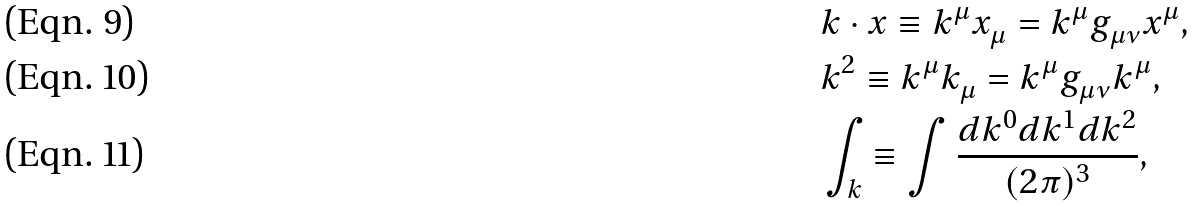Convert formula to latex. <formula><loc_0><loc_0><loc_500><loc_500>& k \cdot x \equiv k ^ { \mu } x ^ { \ } _ { \mu } = k ^ { \mu } g ^ { \ } _ { \mu \nu } x ^ { \mu } , \\ & k ^ { 2 } \equiv k ^ { \mu } k ^ { \ } _ { \mu } = k ^ { \mu } g ^ { \ } _ { \mu \nu } k ^ { \mu } , \\ & \int _ { k } \equiv \int \frac { d k ^ { 0 } d k ^ { 1 } d k ^ { 2 } } { ( 2 \pi ) ^ { 3 } } ,</formula> 